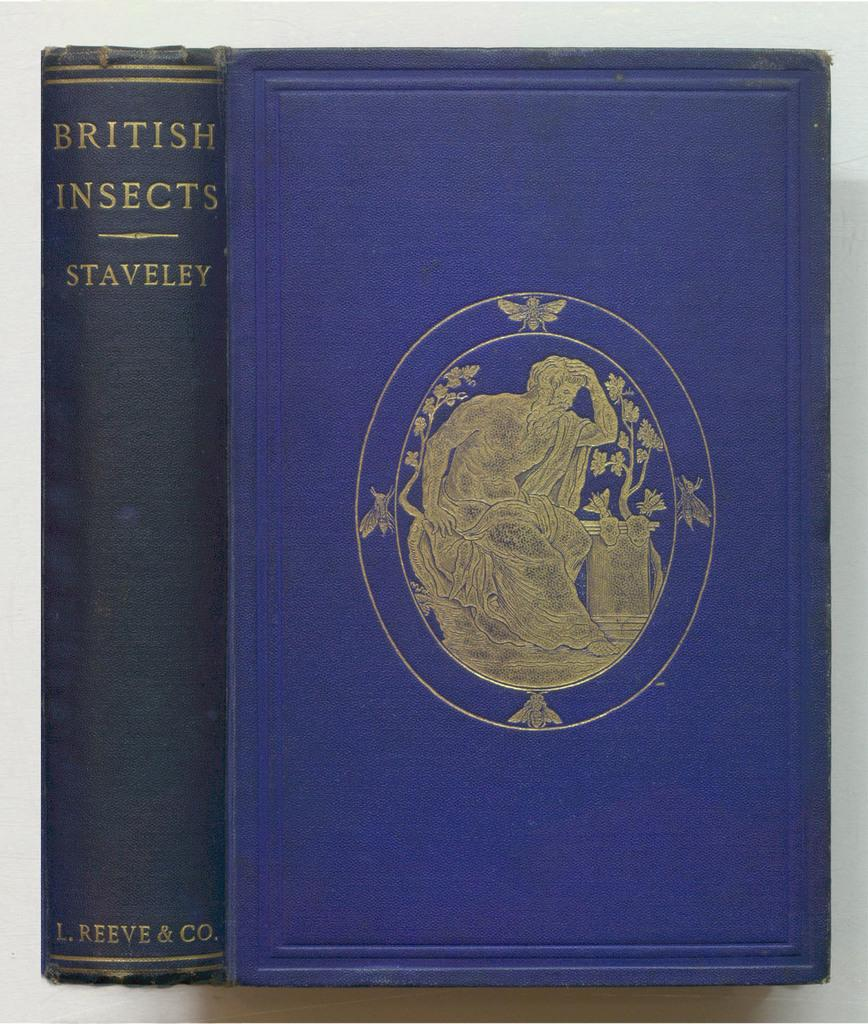What object is present in the image? There is a book in the image. Can you describe the appearance of the book? The book appears to be blue in color. How many times does the person in the image sneeze while reading the book? There is no person present in the image, so it is not possible to determine how many times they sneeze while reading the book. 